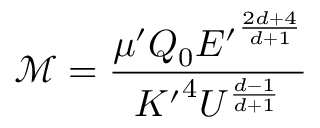<formula> <loc_0><loc_0><loc_500><loc_500>\mathcal { M } = \frac { \mu ^ { \prime } Q _ { 0 } { E ^ { \prime } } ^ { \frac { 2 d + 4 } { d + 1 } } } { { K ^ { \prime } } ^ { 4 } U ^ { \frac { d - 1 } { d + 1 } } }</formula> 